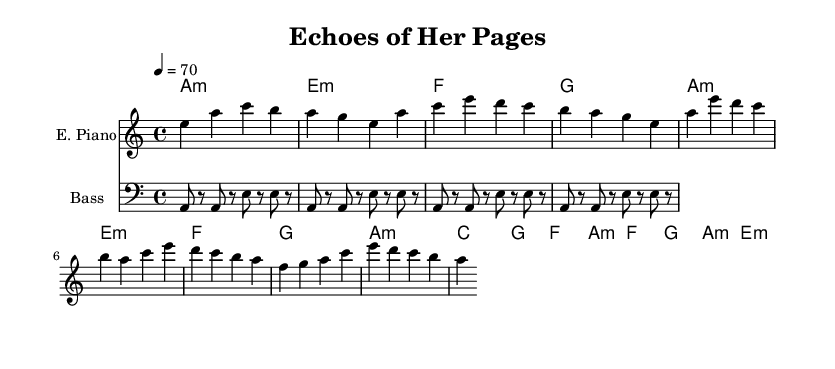What is the key signature of this music? The key signature is A minor, which has no sharps or flats.
Answer: A minor What is the time signature of this composition? The time signature shown is 4/4, meaning there are four beats in a measure.
Answer: 4/4 What is the tempo marking indicated in the sheet music? The tempo marking is 70 beats per minute, which is generally a moderate pace for the music.
Answer: 70 How many measures are there in the verse section? By counting the notes in the verse from the sheet music, there are a total of 4 measures.
Answer: 4 Which chord is played during the chorus? The first chord in the chorus is C major, indicated in the chord names at the beginning of that section.
Answer: C What type of instrument is indicated for the first staff? The first staff specifies "E. Piano," indicating the style of instrument to be used for that part.
Answer: E. Piano What is the characteristic feature of the bass line in this funk piece? The bass line presents a simplified syncopated pattern typical of funk music, which adds a rhythmic groove.
Answer: Syncopated pattern 